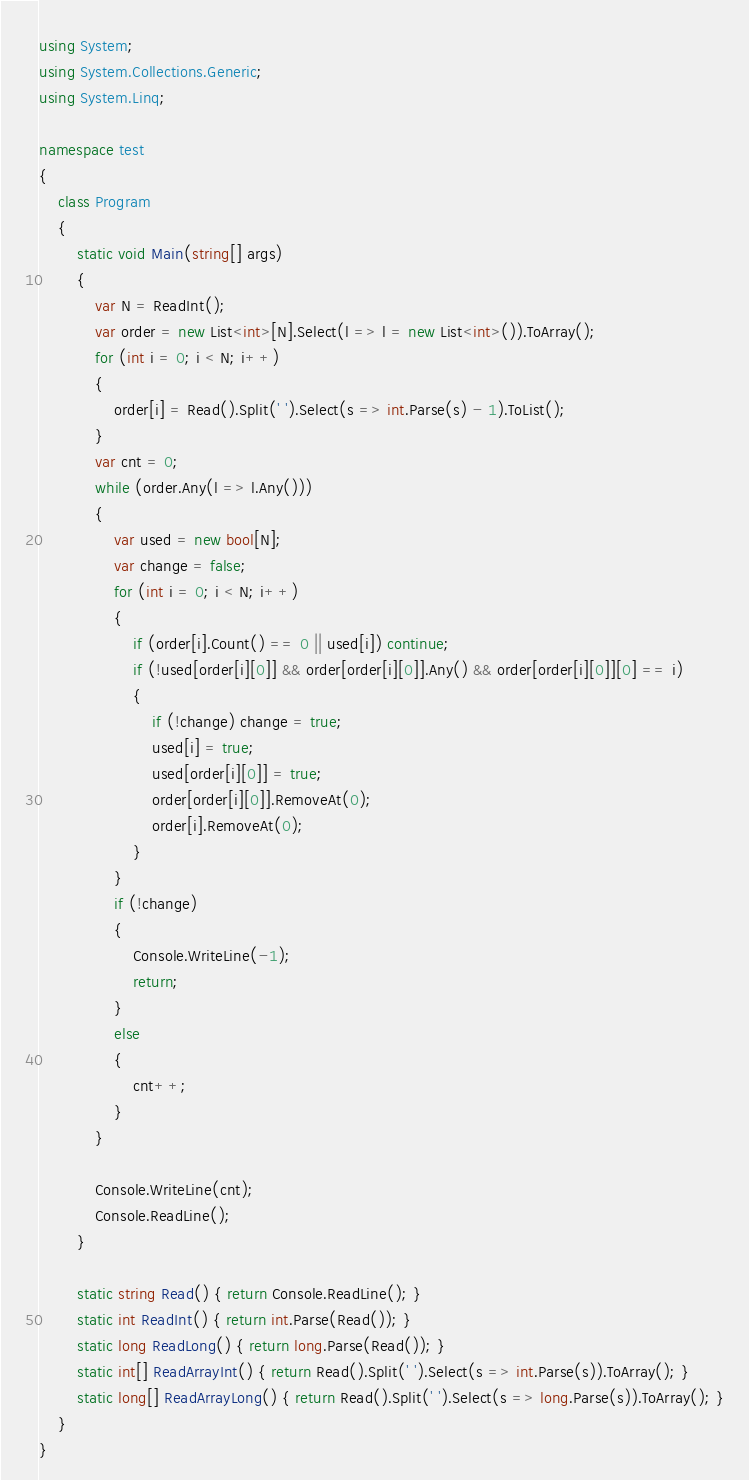<code> <loc_0><loc_0><loc_500><loc_500><_C#_>using System;
using System.Collections.Generic;
using System.Linq;

namespace test
{
    class Program
    {
        static void Main(string[] args)
        {
            var N = ReadInt();
            var order = new List<int>[N].Select(l => l = new List<int>()).ToArray();
            for (int i = 0; i < N; i++)
            {
                order[i] = Read().Split(' ').Select(s => int.Parse(s) - 1).ToList();
            }
            var cnt = 0;
            while (order.Any(l => l.Any()))
            {
                var used = new bool[N];
                var change = false;
                for (int i = 0; i < N; i++)
                {
                    if (order[i].Count() == 0 || used[i]) continue;
                    if (!used[order[i][0]] && order[order[i][0]].Any() && order[order[i][0]][0] == i)
                    {
                        if (!change) change = true;
                        used[i] = true;
                        used[order[i][0]] = true;
                        order[order[i][0]].RemoveAt(0);
                        order[i].RemoveAt(0);
                    }
                }
                if (!change)
                {
                    Console.WriteLine(-1);
                    return;
                }
                else
                {
                    cnt++;
                }
            }

            Console.WriteLine(cnt);
            Console.ReadLine();
        }

        static string Read() { return Console.ReadLine(); }
        static int ReadInt() { return int.Parse(Read()); }
        static long ReadLong() { return long.Parse(Read()); }
        static int[] ReadArrayInt() { return Read().Split(' ').Select(s => int.Parse(s)).ToArray(); }
        static long[] ReadArrayLong() { return Read().Split(' ').Select(s => long.Parse(s)).ToArray(); }
    }
}</code> 